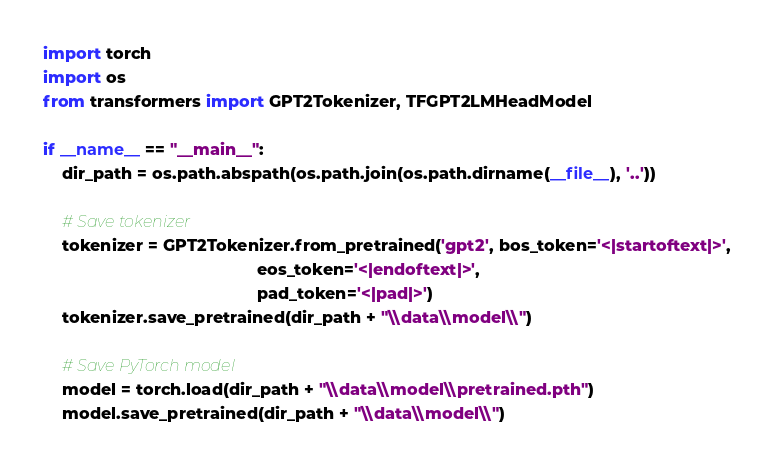<code> <loc_0><loc_0><loc_500><loc_500><_Python_>import torch
import os
from transformers import GPT2Tokenizer, TFGPT2LMHeadModel

if __name__ == "__main__":
    dir_path = os.path.abspath(os.path.join(os.path.dirname(__file__), '..'))

    # Save tokenizer
    tokenizer = GPT2Tokenizer.from_pretrained('gpt2', bos_token='<|startoftext|>',
                                              eos_token='<|endoftext|>',
                                              pad_token='<|pad|>')
    tokenizer.save_pretrained(dir_path + "\\data\\model\\")

    # Save PyTorch model
    model = torch.load(dir_path + "\\data\\model\\pretrained.pth")
    model.save_pretrained(dir_path + "\\data\\model\\")

</code> 